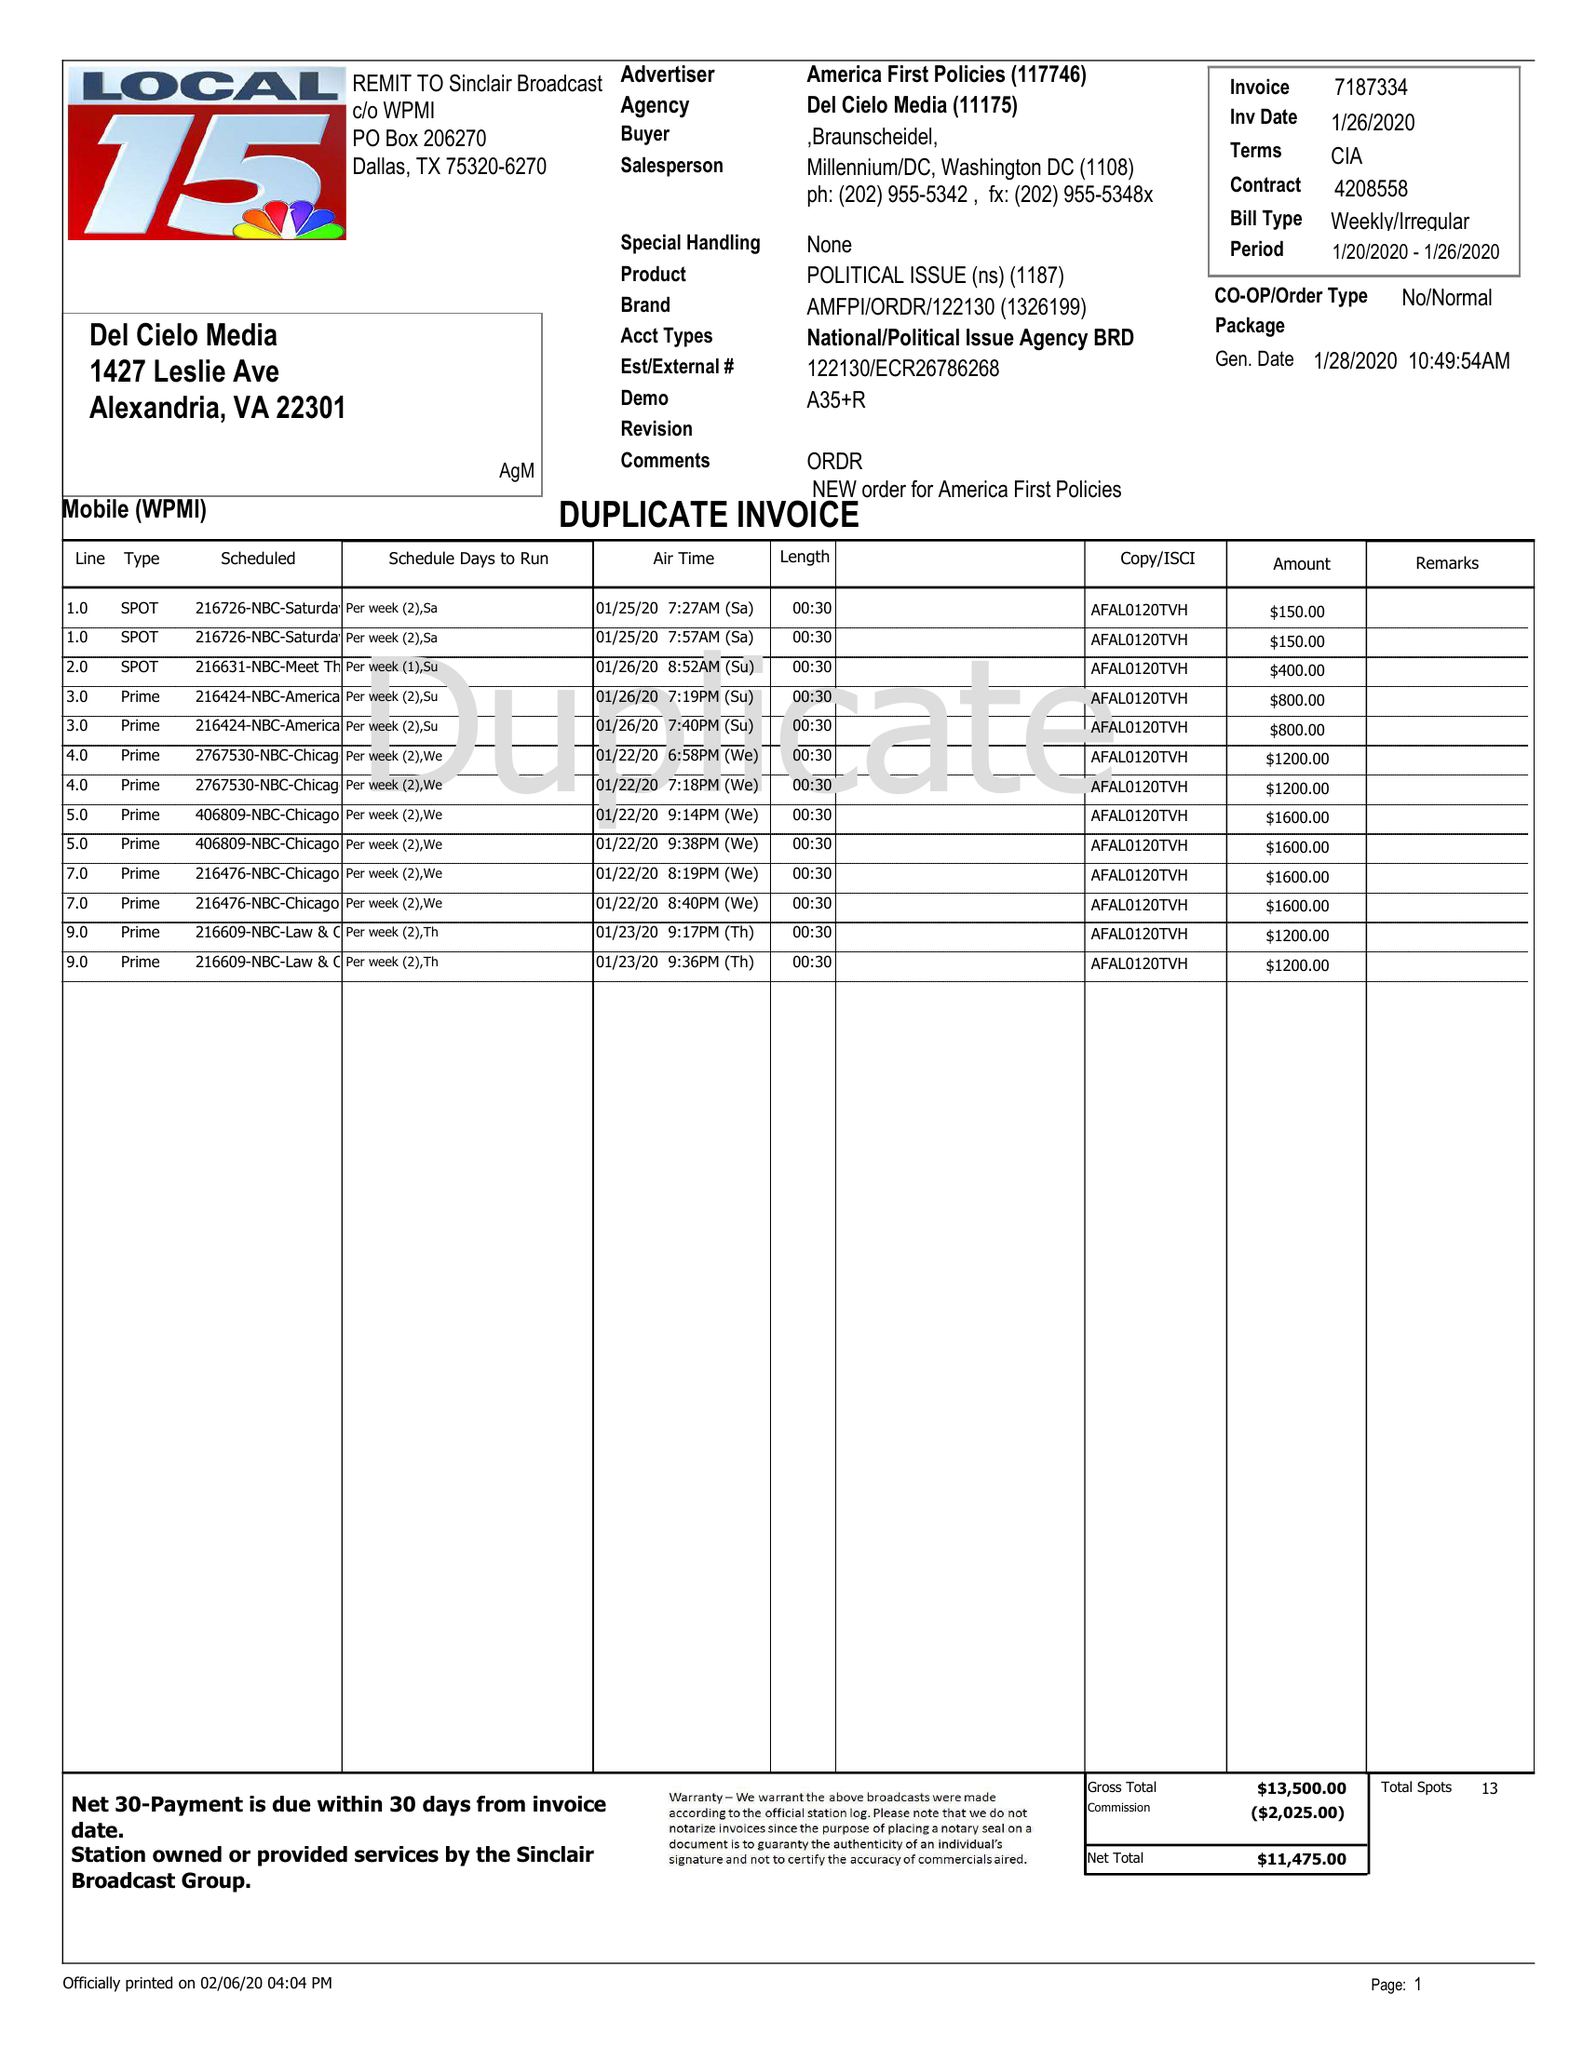What is the value for the advertiser?
Answer the question using a single word or phrase. AMERICA FIRST POLICIES 